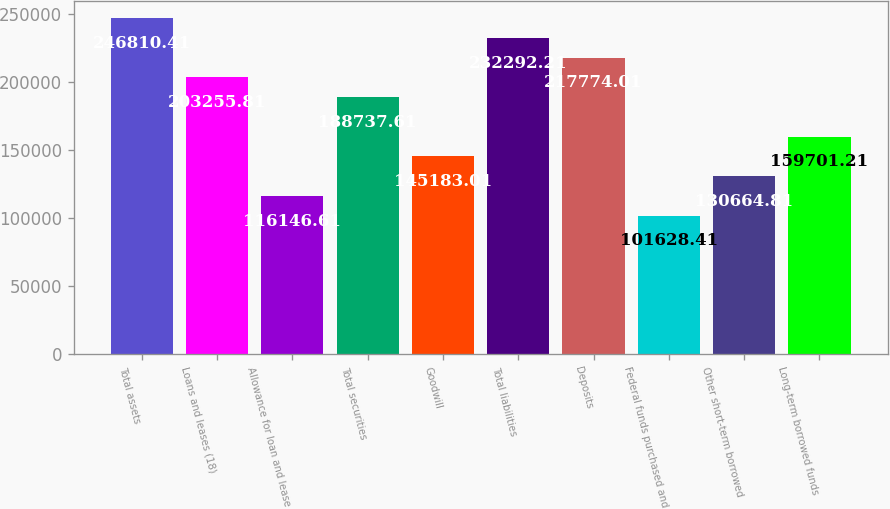<chart> <loc_0><loc_0><loc_500><loc_500><bar_chart><fcel>Total assets<fcel>Loans and leases (18)<fcel>Allowance for loan and lease<fcel>Total securities<fcel>Goodwill<fcel>Total liabilities<fcel>Deposits<fcel>Federal funds purchased and<fcel>Other short-term borrowed<fcel>Long-term borrowed funds<nl><fcel>246810<fcel>203256<fcel>116147<fcel>188738<fcel>145183<fcel>232292<fcel>217774<fcel>101628<fcel>130665<fcel>159701<nl></chart> 